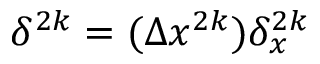<formula> <loc_0><loc_0><loc_500><loc_500>\delta ^ { 2 k } = ( \Delta x ^ { 2 k } ) \delta _ { x } ^ { 2 k }</formula> 